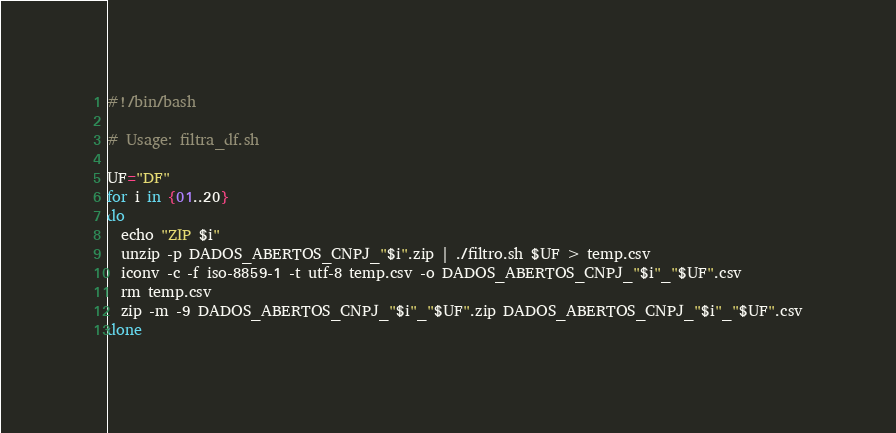<code> <loc_0><loc_0><loc_500><loc_500><_Bash_>#!/bin/bash

# Usage: filtra_df.sh

UF="DF"
for i in {01..20}
do
  echo "ZIP $i"
  unzip -p DADOS_ABERTOS_CNPJ_"$i".zip | ./filtro.sh $UF > temp.csv
  iconv -c -f iso-8859-1 -t utf-8 temp.csv -o DADOS_ABERTOS_CNPJ_"$i"_"$UF".csv
  rm temp.csv
  zip -m -9 DADOS_ABERTOS_CNPJ_"$i"_"$UF".zip DADOS_ABERTOS_CNPJ_"$i"_"$UF".csv
done
</code> 